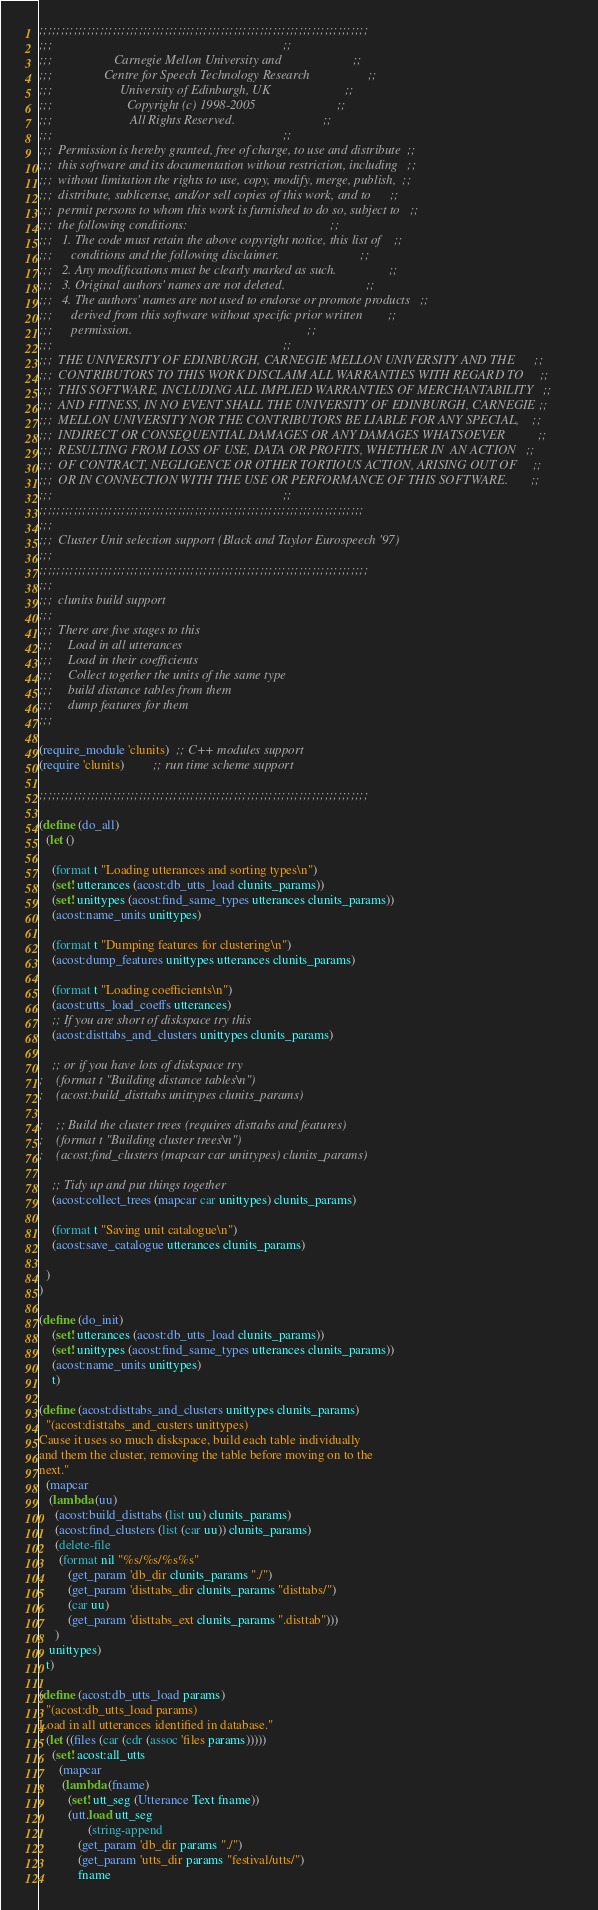Convert code to text. <code><loc_0><loc_0><loc_500><loc_500><_Scheme_>;;;;;;;;;;;;;;;;;;;;;;;;;;;;;;;;;;;;;;;;;;;;;;;;;;;;;;;;;;;;;;;;;;;;;;;;;;;;
;;;                                                                       ;;
;;;                   Carnegie Mellon University and                      ;;
;;;                Centre for Speech Technology Research                  ;;
;;;                     University of Edinburgh, UK                       ;;
;;;                       Copyright (c) 1998-2005                         ;;
;;;                        All Rights Reserved.                           ;;
;;;                                                                       ;;
;;;  Permission is hereby granted, free of charge, to use and distribute  ;;
;;;  this software and its documentation without restriction, including   ;;
;;;  without limitation the rights to use, copy, modify, merge, publish,  ;;
;;;  distribute, sublicense, and/or sell copies of this work, and to      ;;
;;;  permit persons to whom this work is furnished to do so, subject to   ;;
;;;  the following conditions:                                            ;;
;;;   1. The code must retain the above copyright notice, this list of    ;;
;;;      conditions and the following disclaimer.                         ;;
;;;   2. Any modifications must be clearly marked as such.                ;;
;;;   3. Original authors' names are not deleted.                         ;;
;;;   4. The authors' names are not used to endorse or promote products   ;;
;;;      derived from this software without specific prior written        ;;
;;;      permission.                                                      ;;
;;;                                                                       ;;
;;;  THE UNIVERSITY OF EDINBURGH, CARNEGIE MELLON UNIVERSITY AND THE      ;;
;;;  CONTRIBUTORS TO THIS WORK DISCLAIM ALL WARRANTIES WITH REGARD TO     ;;
;;;  THIS SOFTWARE, INCLUDING ALL IMPLIED WARRANTIES OF MERCHANTABILITY   ;;
;;;  AND FITNESS, IN NO EVENT SHALL THE UNIVERSITY OF EDINBURGH, CARNEGIE ;;
;;;  MELLON UNIVERSITY NOR THE CONTRIBUTORS BE LIABLE FOR ANY SPECIAL,    ;;
;;;  INDIRECT OR CONSEQUENTIAL DAMAGES OR ANY DAMAGES WHATSOEVER          ;;
;;;  RESULTING FROM LOSS OF USE, DATA OR PROFITS, WHETHER IN  AN ACTION   ;;
;;;  OF CONTRACT, NEGLIGENCE OR OTHER TORTIOUS ACTION, ARISING OUT OF     ;;
;;;  OR IN CONNECTION WITH THE USE OR PERFORMANCE OF THIS SOFTWARE.       ;;
;;;                                                                       ;;
;;;;;;;;;;;;;;;;;;;;;;;;;;;;;;;;;;;;;;;;;;;;;;;;;;;;;;;;;;;;;;;;;;;;;;;;;;;
;;;
;;;  Cluster Unit selection support (Black and Taylor Eurospeech '97)
;;;
;;;;;;;;;;;;;;;;;;;;;;;;;;;;;;;;;;;;;;;;;;;;;;;;;;;;;;;;;;;;;;;;;;;;;;;;;;;;
;;;
;;;  clunits build support
;;;
;;;  There are five stages to this
;;;     Load in all utterances
;;;     Load in their coefficients
;;;     Collect together the units of the same type
;;;     build distance tables from them
;;;     dump features for them
;;;

(require_module 'clunits)  ;; C++ modules support
(require 'clunits)         ;; run time scheme support

;;;;;;;;;;;;;;;;;;;;;;;;;;;;;;;;;;;;;;;;;;;;;;;;;;;;;;;;;;;;;;;;;;;;;;;;;;;;

(define (do_all)
  (let ()

    (format t "Loading utterances and sorting types\n")
    (set! utterances (acost:db_utts_load clunits_params))
    (set! unittypes (acost:find_same_types utterances clunits_params))
    (acost:name_units unittypes)

    (format t "Dumping features for clustering\n")
    (acost:dump_features unittypes utterances clunits_params)

    (format t "Loading coefficients\n")
    (acost:utts_load_coeffs utterances)
    ;; If you are short of diskspace try this
    (acost:disttabs_and_clusters unittypes clunits_params)

    ;; or if you have lots of diskspace try
;    (format t "Building distance tables\n")
;    (acost:build_disttabs unittypes clunits_params)

;    ;; Build the cluster trees (requires disttabs and features)
;    (format t "Building cluster trees\n")
;    (acost:find_clusters (mapcar car unittypes) clunits_params)

    ;; Tidy up and put things together
    (acost:collect_trees (mapcar car unittypes) clunits_params)
    
    (format t "Saving unit catalogue\n")
    (acost:save_catalogue utterances clunits_params)
    
  )
)

(define (do_init)
    (set! utterances (acost:db_utts_load clunits_params))
    (set! unittypes (acost:find_same_types utterances clunits_params))
    (acost:name_units unittypes)
    t)

(define (acost:disttabs_and_clusters unittypes clunits_params)
  "(acost:disttabs_and_custers unittypes)
Cause it uses so much diskspace, build each table individually
and them the cluster, removing the table before moving on to the
next."
  (mapcar
   (lambda (uu)
     (acost:build_disttabs (list uu) clunits_params)
     (acost:find_clusters (list (car uu)) clunits_params)
     (delete-file 
      (format nil "%s/%s/%s%s" 
	     (get_param 'db_dir clunits_params "./")
	     (get_param 'disttabs_dir clunits_params "disttabs/")
	     (car uu)
	     (get_param 'disttabs_ext clunits_params ".disttab")))
     )
   unittypes)
  t)

(define (acost:db_utts_load params)
  "(acost:db_utts_load params)
Load in all utterances identified in database."
  (let ((files (car (cdr (assoc 'files params)))))
    (set! acost:all_utts
	  (mapcar
	   (lambda (fname)
	     (set! utt_seg (Utterance Text fname))
	     (utt.load utt_seg 
		       (string-append 
			(get_param 'db_dir params "./")
			(get_param 'utts_dir params "festival/utts/")
			fname</code> 